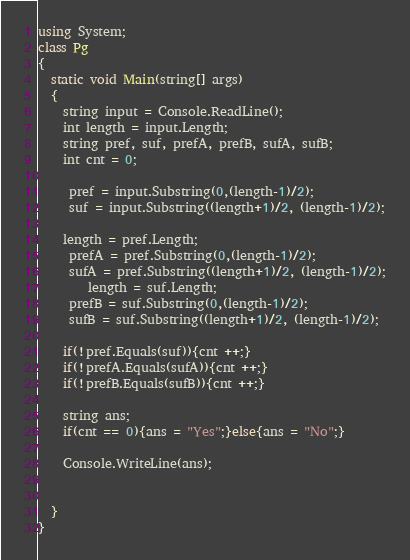<code> <loc_0><loc_0><loc_500><loc_500><_C#_>using System;
class Pg
{
  static void Main(string[] args)
  {
    string input = Console.ReadLine();
    int length = input.Length;
    string pref, suf, prefA, prefB, sufA, sufB;
    int cnt = 0;
    
     pref = input.Substring(0,(length-1)/2);
     suf = input.Substring((length+1)/2, (length-1)/2);
    
    length = pref.Length;
     prefA = pref.Substring(0,(length-1)/2);
     sufA = pref.Substring((length+1)/2, (length-1)/2);
        length = suf.Length;
     prefB = suf.Substring(0,(length-1)/2);
     sufB = suf.Substring((length+1)/2, (length-1)/2);
    
    if(!pref.Equals(suf)){cnt ++;}
    if(!prefA.Equals(sufA)){cnt ++;}
    if(!prefB.Equals(sufB)){cnt ++;}
    
    string ans;
    if(cnt == 0){ans = "Yes";}else{ans = "No";}
    
    Console.WriteLine(ans);
  
    
  }
}</code> 